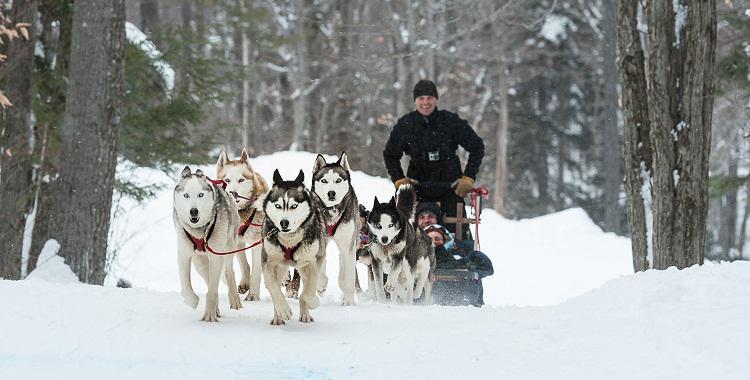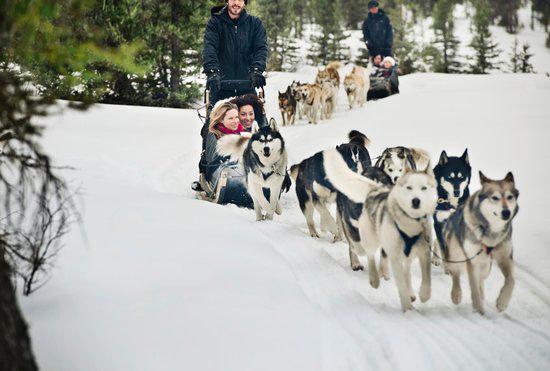The first image is the image on the left, the second image is the image on the right. Assess this claim about the two images: "The lead dog sled teams in the left and right images head forward but are angled slightly away from each other so they would not collide.". Correct or not? Answer yes or no. Yes. 